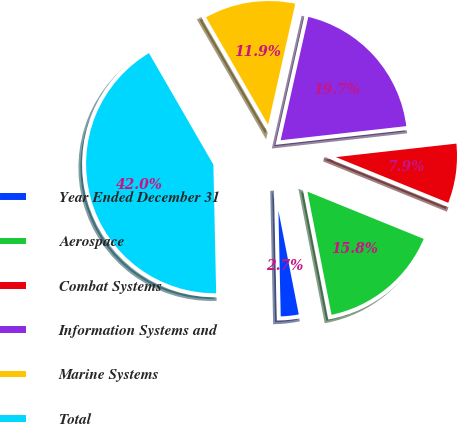<chart> <loc_0><loc_0><loc_500><loc_500><pie_chart><fcel>Year Ended December 31<fcel>Aerospace<fcel>Combat Systems<fcel>Information Systems and<fcel>Marine Systems<fcel>Total<nl><fcel>2.73%<fcel>15.78%<fcel>7.92%<fcel>19.71%<fcel>11.85%<fcel>42.01%<nl></chart> 